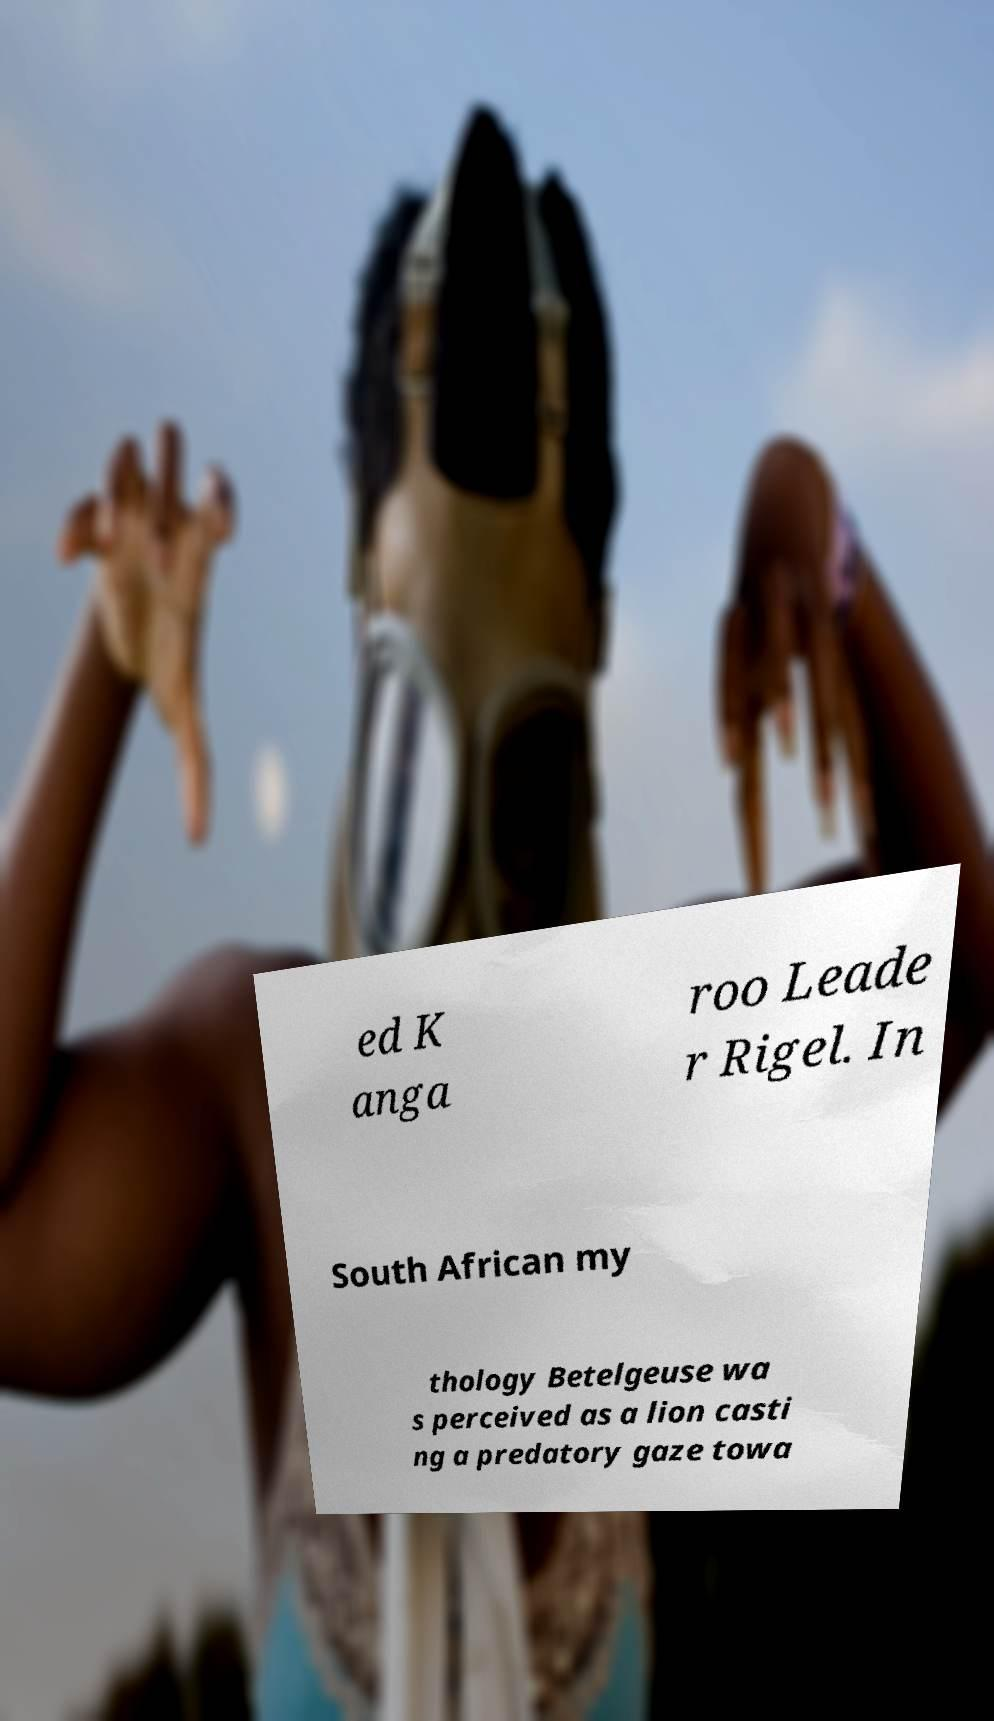Can you read and provide the text displayed in the image?This photo seems to have some interesting text. Can you extract and type it out for me? ed K anga roo Leade r Rigel. In South African my thology Betelgeuse wa s perceived as a lion casti ng a predatory gaze towa 